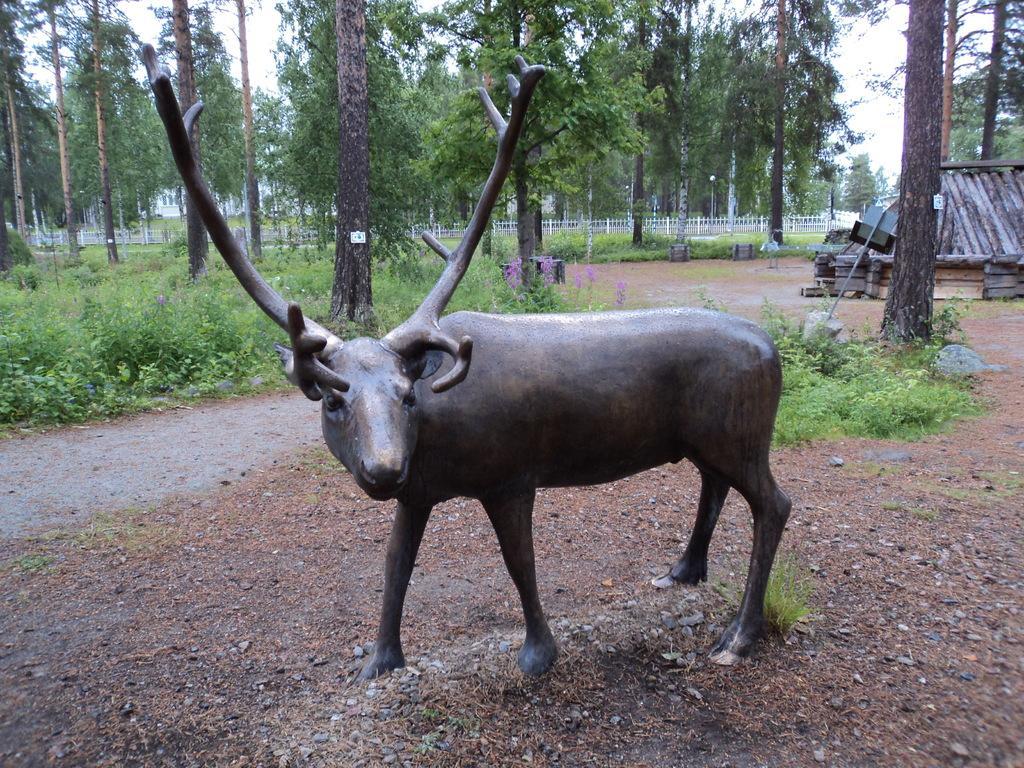Please provide a concise description of this image. In this picture we can observe a statue of an antelope which is in brown color. We can observe some plants and trees. In the background we can observe white color railing. There is a sky. 